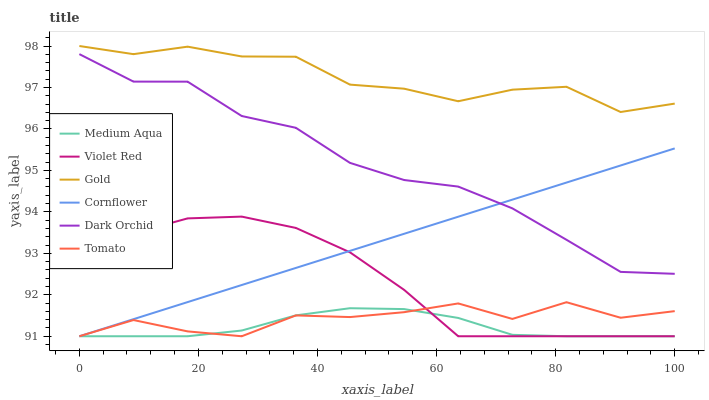Does Medium Aqua have the minimum area under the curve?
Answer yes or no. Yes. Does Gold have the maximum area under the curve?
Answer yes or no. Yes. Does Cornflower have the minimum area under the curve?
Answer yes or no. No. Does Cornflower have the maximum area under the curve?
Answer yes or no. No. Is Cornflower the smoothest?
Answer yes or no. Yes. Is Tomato the roughest?
Answer yes or no. Yes. Is Violet Red the smoothest?
Answer yes or no. No. Is Violet Red the roughest?
Answer yes or no. No. Does Tomato have the lowest value?
Answer yes or no. Yes. Does Gold have the lowest value?
Answer yes or no. No. Does Gold have the highest value?
Answer yes or no. Yes. Does Cornflower have the highest value?
Answer yes or no. No. Is Medium Aqua less than Gold?
Answer yes or no. Yes. Is Gold greater than Dark Orchid?
Answer yes or no. Yes. Does Medium Aqua intersect Tomato?
Answer yes or no. Yes. Is Medium Aqua less than Tomato?
Answer yes or no. No. Is Medium Aqua greater than Tomato?
Answer yes or no. No. Does Medium Aqua intersect Gold?
Answer yes or no. No. 